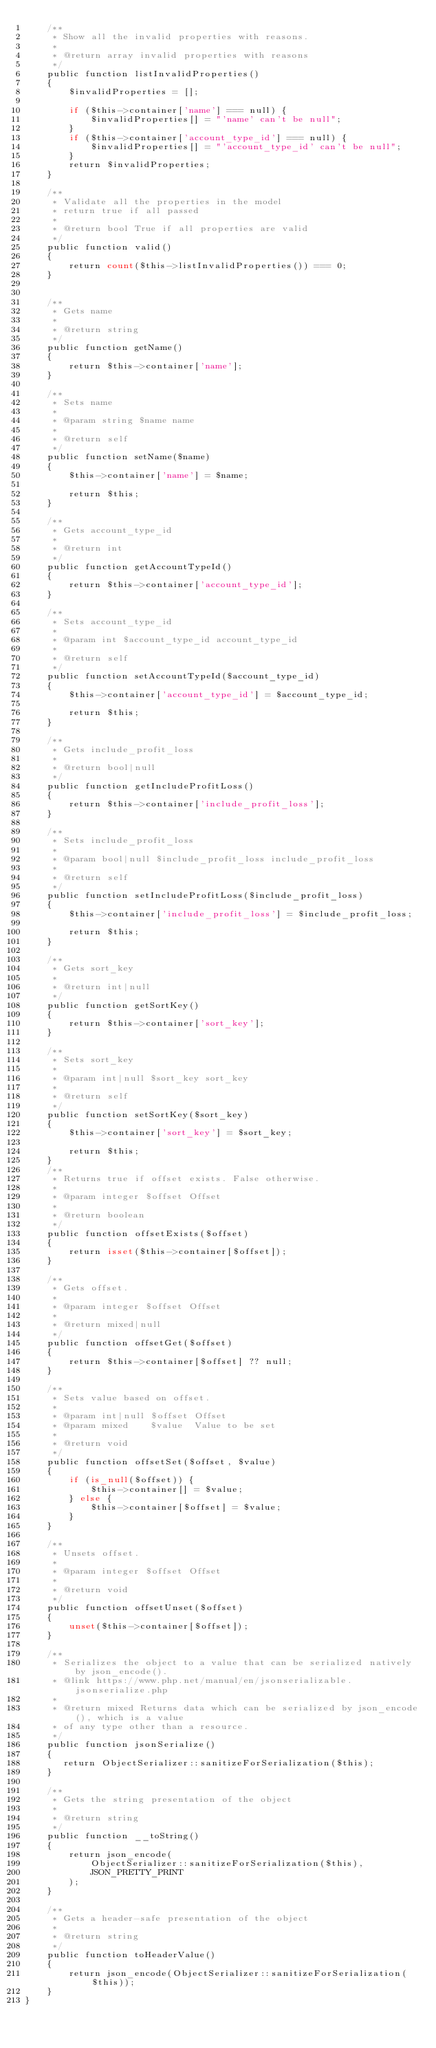Convert code to text. <code><loc_0><loc_0><loc_500><loc_500><_PHP_>    /**
     * Show all the invalid properties with reasons.
     *
     * @return array invalid properties with reasons
     */
    public function listInvalidProperties()
    {
        $invalidProperties = [];

        if ($this->container['name'] === null) {
            $invalidProperties[] = "'name' can't be null";
        }
        if ($this->container['account_type_id'] === null) {
            $invalidProperties[] = "'account_type_id' can't be null";
        }
        return $invalidProperties;
    }

    /**
     * Validate all the properties in the model
     * return true if all passed
     *
     * @return bool True if all properties are valid
     */
    public function valid()
    {
        return count($this->listInvalidProperties()) === 0;
    }


    /**
     * Gets name
     *
     * @return string
     */
    public function getName()
    {
        return $this->container['name'];
    }

    /**
     * Sets name
     *
     * @param string $name name
     *
     * @return self
     */
    public function setName($name)
    {
        $this->container['name'] = $name;

        return $this;
    }

    /**
     * Gets account_type_id
     *
     * @return int
     */
    public function getAccountTypeId()
    {
        return $this->container['account_type_id'];
    }

    /**
     * Sets account_type_id
     *
     * @param int $account_type_id account_type_id
     *
     * @return self
     */
    public function setAccountTypeId($account_type_id)
    {
        $this->container['account_type_id'] = $account_type_id;

        return $this;
    }

    /**
     * Gets include_profit_loss
     *
     * @return bool|null
     */
    public function getIncludeProfitLoss()
    {
        return $this->container['include_profit_loss'];
    }

    /**
     * Sets include_profit_loss
     *
     * @param bool|null $include_profit_loss include_profit_loss
     *
     * @return self
     */
    public function setIncludeProfitLoss($include_profit_loss)
    {
        $this->container['include_profit_loss'] = $include_profit_loss;

        return $this;
    }

    /**
     * Gets sort_key
     *
     * @return int|null
     */
    public function getSortKey()
    {
        return $this->container['sort_key'];
    }

    /**
     * Sets sort_key
     *
     * @param int|null $sort_key sort_key
     *
     * @return self
     */
    public function setSortKey($sort_key)
    {
        $this->container['sort_key'] = $sort_key;

        return $this;
    }
    /**
     * Returns true if offset exists. False otherwise.
     *
     * @param integer $offset Offset
     *
     * @return boolean
     */
    public function offsetExists($offset)
    {
        return isset($this->container[$offset]);
    }

    /**
     * Gets offset.
     *
     * @param integer $offset Offset
     *
     * @return mixed|null
     */
    public function offsetGet($offset)
    {
        return $this->container[$offset] ?? null;
    }

    /**
     * Sets value based on offset.
     *
     * @param int|null $offset Offset
     * @param mixed    $value  Value to be set
     *
     * @return void
     */
    public function offsetSet($offset, $value)
    {
        if (is_null($offset)) {
            $this->container[] = $value;
        } else {
            $this->container[$offset] = $value;
        }
    }

    /**
     * Unsets offset.
     *
     * @param integer $offset Offset
     *
     * @return void
     */
    public function offsetUnset($offset)
    {
        unset($this->container[$offset]);
    }

    /**
     * Serializes the object to a value that can be serialized natively by json_encode().
     * @link https://www.php.net/manual/en/jsonserializable.jsonserialize.php
     *
     * @return mixed Returns data which can be serialized by json_encode(), which is a value
     * of any type other than a resource.
     */
    public function jsonSerialize()
    {
       return ObjectSerializer::sanitizeForSerialization($this);
    }

    /**
     * Gets the string presentation of the object
     *
     * @return string
     */
    public function __toString()
    {
        return json_encode(
            ObjectSerializer::sanitizeForSerialization($this),
            JSON_PRETTY_PRINT
        );
    }

    /**
     * Gets a header-safe presentation of the object
     *
     * @return string
     */
    public function toHeaderValue()
    {
        return json_encode(ObjectSerializer::sanitizeForSerialization($this));
    }
}


</code> 